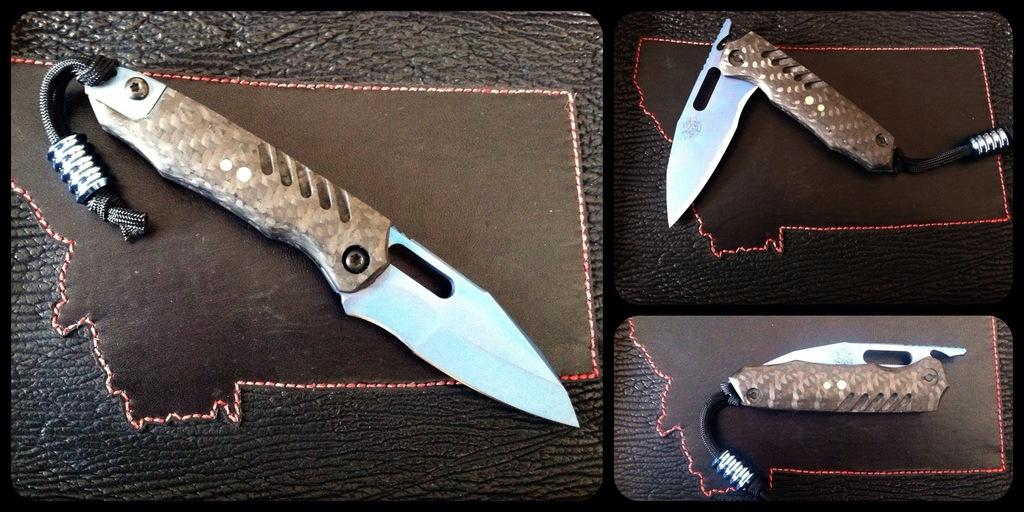What piece of furniture is present in the image? There is a table in the image. What objects are on the table? There are knives on the table. What type of grass can be seen growing on the table in the image? There is no grass present on the table in the image. Is there a jail visible in the image? There is no jail present in the image. 